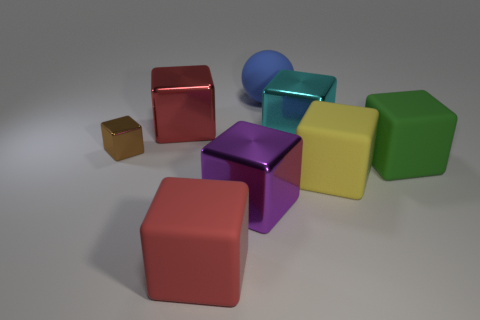Subtract 3 blocks. How many blocks are left? 4 Subtract all green blocks. How many blocks are left? 6 Subtract all yellow cubes. How many cubes are left? 6 Subtract all red blocks. Subtract all yellow balls. How many blocks are left? 5 Add 2 large red matte cubes. How many objects exist? 10 Subtract all spheres. How many objects are left? 7 Subtract 1 blue spheres. How many objects are left? 7 Subtract all tiny metal objects. Subtract all rubber balls. How many objects are left? 6 Add 2 big purple shiny blocks. How many big purple shiny blocks are left? 3 Add 1 purple blocks. How many purple blocks exist? 2 